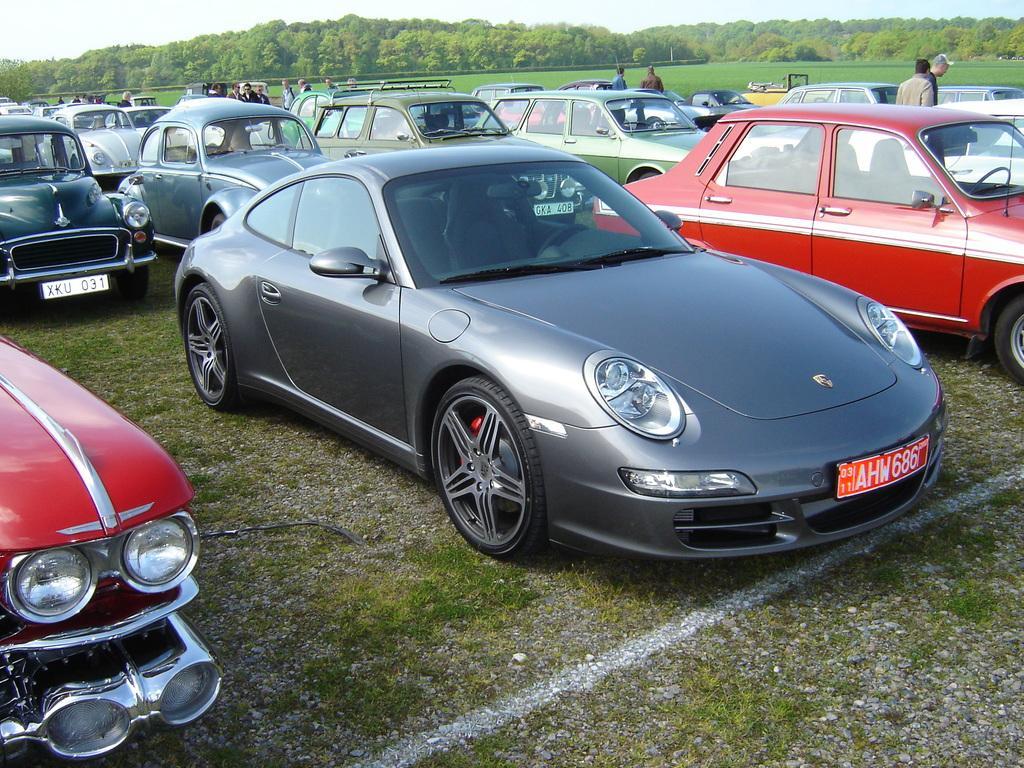How would you summarize this image in a sentence or two? In this image we can see a group of cars parked on the ground. We can also see a group of people standing beside them. On the backside we can see some grass, a group of trees and the sky. 